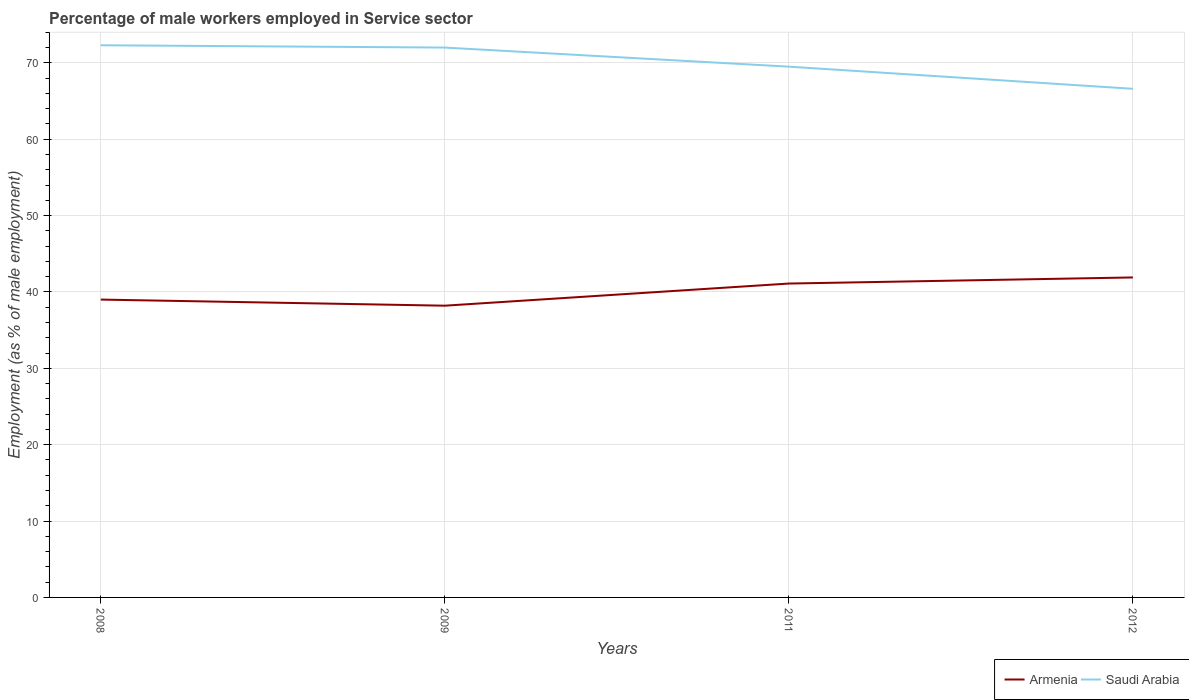Across all years, what is the maximum percentage of male workers employed in Service sector in Armenia?
Provide a short and direct response. 38.2. What is the total percentage of male workers employed in Service sector in Armenia in the graph?
Make the answer very short. -2.9. What is the difference between the highest and the second highest percentage of male workers employed in Service sector in Saudi Arabia?
Provide a short and direct response. 5.7. What is the difference between the highest and the lowest percentage of male workers employed in Service sector in Armenia?
Make the answer very short. 2. Does the graph contain any zero values?
Your answer should be compact. No. Where does the legend appear in the graph?
Keep it short and to the point. Bottom right. How are the legend labels stacked?
Make the answer very short. Horizontal. What is the title of the graph?
Your answer should be compact. Percentage of male workers employed in Service sector. What is the label or title of the Y-axis?
Ensure brevity in your answer.  Employment (as % of male employment). What is the Employment (as % of male employment) of Armenia in 2008?
Provide a succinct answer. 39. What is the Employment (as % of male employment) of Saudi Arabia in 2008?
Provide a short and direct response. 72.3. What is the Employment (as % of male employment) in Armenia in 2009?
Make the answer very short. 38.2. What is the Employment (as % of male employment) of Armenia in 2011?
Offer a very short reply. 41.1. What is the Employment (as % of male employment) in Saudi Arabia in 2011?
Offer a very short reply. 69.5. What is the Employment (as % of male employment) of Armenia in 2012?
Your answer should be very brief. 41.9. What is the Employment (as % of male employment) in Saudi Arabia in 2012?
Provide a succinct answer. 66.6. Across all years, what is the maximum Employment (as % of male employment) of Armenia?
Provide a short and direct response. 41.9. Across all years, what is the maximum Employment (as % of male employment) of Saudi Arabia?
Offer a very short reply. 72.3. Across all years, what is the minimum Employment (as % of male employment) of Armenia?
Your answer should be very brief. 38.2. Across all years, what is the minimum Employment (as % of male employment) in Saudi Arabia?
Offer a very short reply. 66.6. What is the total Employment (as % of male employment) in Armenia in the graph?
Your answer should be very brief. 160.2. What is the total Employment (as % of male employment) in Saudi Arabia in the graph?
Offer a very short reply. 280.4. What is the difference between the Employment (as % of male employment) of Armenia in 2008 and that in 2009?
Make the answer very short. 0.8. What is the difference between the Employment (as % of male employment) in Saudi Arabia in 2008 and that in 2011?
Make the answer very short. 2.8. What is the difference between the Employment (as % of male employment) in Armenia in 2009 and that in 2011?
Offer a very short reply. -2.9. What is the difference between the Employment (as % of male employment) of Armenia in 2011 and that in 2012?
Provide a succinct answer. -0.8. What is the difference between the Employment (as % of male employment) of Saudi Arabia in 2011 and that in 2012?
Provide a succinct answer. 2.9. What is the difference between the Employment (as % of male employment) of Armenia in 2008 and the Employment (as % of male employment) of Saudi Arabia in 2009?
Provide a succinct answer. -33. What is the difference between the Employment (as % of male employment) of Armenia in 2008 and the Employment (as % of male employment) of Saudi Arabia in 2011?
Give a very brief answer. -30.5. What is the difference between the Employment (as % of male employment) in Armenia in 2008 and the Employment (as % of male employment) in Saudi Arabia in 2012?
Provide a succinct answer. -27.6. What is the difference between the Employment (as % of male employment) of Armenia in 2009 and the Employment (as % of male employment) of Saudi Arabia in 2011?
Offer a very short reply. -31.3. What is the difference between the Employment (as % of male employment) of Armenia in 2009 and the Employment (as % of male employment) of Saudi Arabia in 2012?
Give a very brief answer. -28.4. What is the difference between the Employment (as % of male employment) in Armenia in 2011 and the Employment (as % of male employment) in Saudi Arabia in 2012?
Your answer should be very brief. -25.5. What is the average Employment (as % of male employment) of Armenia per year?
Offer a very short reply. 40.05. What is the average Employment (as % of male employment) in Saudi Arabia per year?
Give a very brief answer. 70.1. In the year 2008, what is the difference between the Employment (as % of male employment) in Armenia and Employment (as % of male employment) in Saudi Arabia?
Your answer should be compact. -33.3. In the year 2009, what is the difference between the Employment (as % of male employment) of Armenia and Employment (as % of male employment) of Saudi Arabia?
Offer a very short reply. -33.8. In the year 2011, what is the difference between the Employment (as % of male employment) of Armenia and Employment (as % of male employment) of Saudi Arabia?
Your response must be concise. -28.4. In the year 2012, what is the difference between the Employment (as % of male employment) of Armenia and Employment (as % of male employment) of Saudi Arabia?
Your response must be concise. -24.7. What is the ratio of the Employment (as % of male employment) in Armenia in 2008 to that in 2009?
Keep it short and to the point. 1.02. What is the ratio of the Employment (as % of male employment) of Saudi Arabia in 2008 to that in 2009?
Your response must be concise. 1. What is the ratio of the Employment (as % of male employment) of Armenia in 2008 to that in 2011?
Offer a very short reply. 0.95. What is the ratio of the Employment (as % of male employment) in Saudi Arabia in 2008 to that in 2011?
Provide a short and direct response. 1.04. What is the ratio of the Employment (as % of male employment) of Armenia in 2008 to that in 2012?
Ensure brevity in your answer.  0.93. What is the ratio of the Employment (as % of male employment) in Saudi Arabia in 2008 to that in 2012?
Ensure brevity in your answer.  1.09. What is the ratio of the Employment (as % of male employment) of Armenia in 2009 to that in 2011?
Your answer should be very brief. 0.93. What is the ratio of the Employment (as % of male employment) of Saudi Arabia in 2009 to that in 2011?
Keep it short and to the point. 1.04. What is the ratio of the Employment (as % of male employment) of Armenia in 2009 to that in 2012?
Your answer should be compact. 0.91. What is the ratio of the Employment (as % of male employment) of Saudi Arabia in 2009 to that in 2012?
Provide a succinct answer. 1.08. What is the ratio of the Employment (as % of male employment) in Armenia in 2011 to that in 2012?
Your answer should be very brief. 0.98. What is the ratio of the Employment (as % of male employment) in Saudi Arabia in 2011 to that in 2012?
Provide a succinct answer. 1.04. What is the difference between the highest and the second highest Employment (as % of male employment) of Armenia?
Your answer should be compact. 0.8. What is the difference between the highest and the second highest Employment (as % of male employment) in Saudi Arabia?
Your answer should be very brief. 0.3. What is the difference between the highest and the lowest Employment (as % of male employment) in Armenia?
Offer a terse response. 3.7. 